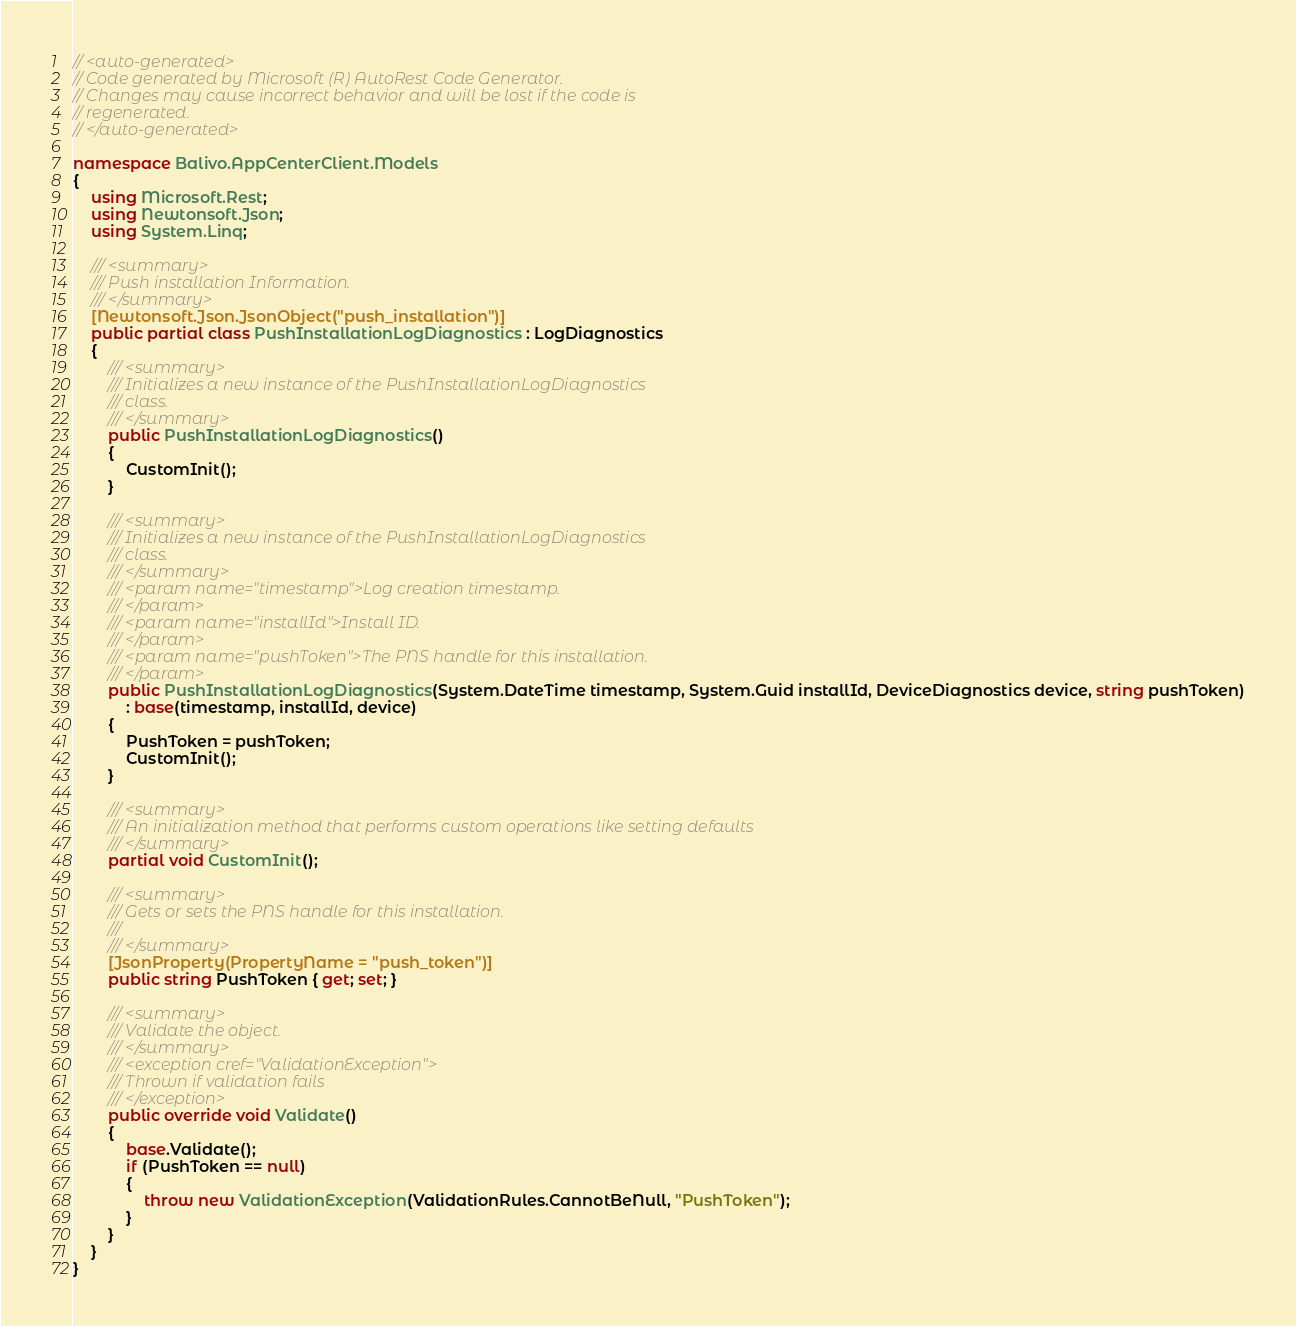<code> <loc_0><loc_0><loc_500><loc_500><_C#_>// <auto-generated>
// Code generated by Microsoft (R) AutoRest Code Generator.
// Changes may cause incorrect behavior and will be lost if the code is
// regenerated.
// </auto-generated>

namespace Balivo.AppCenterClient.Models
{
    using Microsoft.Rest;
    using Newtonsoft.Json;
    using System.Linq;

    /// <summary>
    /// Push installation Information.
    /// </summary>
    [Newtonsoft.Json.JsonObject("push_installation")]
    public partial class PushInstallationLogDiagnostics : LogDiagnostics
    {
        /// <summary>
        /// Initializes a new instance of the PushInstallationLogDiagnostics
        /// class.
        /// </summary>
        public PushInstallationLogDiagnostics()
        {
            CustomInit();
        }

        /// <summary>
        /// Initializes a new instance of the PushInstallationLogDiagnostics
        /// class.
        /// </summary>
        /// <param name="timestamp">Log creation timestamp.
        /// </param>
        /// <param name="installId">Install ID.
        /// </param>
        /// <param name="pushToken">The PNS handle for this installation.
        /// </param>
        public PushInstallationLogDiagnostics(System.DateTime timestamp, System.Guid installId, DeviceDiagnostics device, string pushToken)
            : base(timestamp, installId, device)
        {
            PushToken = pushToken;
            CustomInit();
        }

        /// <summary>
        /// An initialization method that performs custom operations like setting defaults
        /// </summary>
        partial void CustomInit();

        /// <summary>
        /// Gets or sets the PNS handle for this installation.
        ///
        /// </summary>
        [JsonProperty(PropertyName = "push_token")]
        public string PushToken { get; set; }

        /// <summary>
        /// Validate the object.
        /// </summary>
        /// <exception cref="ValidationException">
        /// Thrown if validation fails
        /// </exception>
        public override void Validate()
        {
            base.Validate();
            if (PushToken == null)
            {
                throw new ValidationException(ValidationRules.CannotBeNull, "PushToken");
            }
        }
    }
}
</code> 